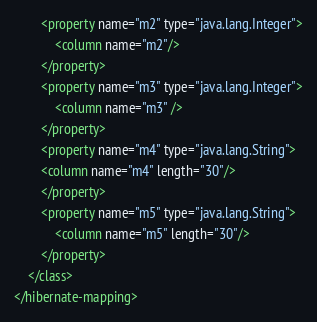Convert code to text. <code><loc_0><loc_0><loc_500><loc_500><_XML_>        <property name="m2" type="java.lang.Integer">
            <column name="m2"/>
        </property>
        <property name="m3" type="java.lang.Integer">
            <column name="m3" />
        </property>
        <property name="m4" type="java.lang.String">
        <column name="m4" length="30"/>
        </property>
        <property name="m5" type="java.lang.String">
            <column name="m5" length="30"/>
        </property>
    </class>
</hibernate-mapping></code> 